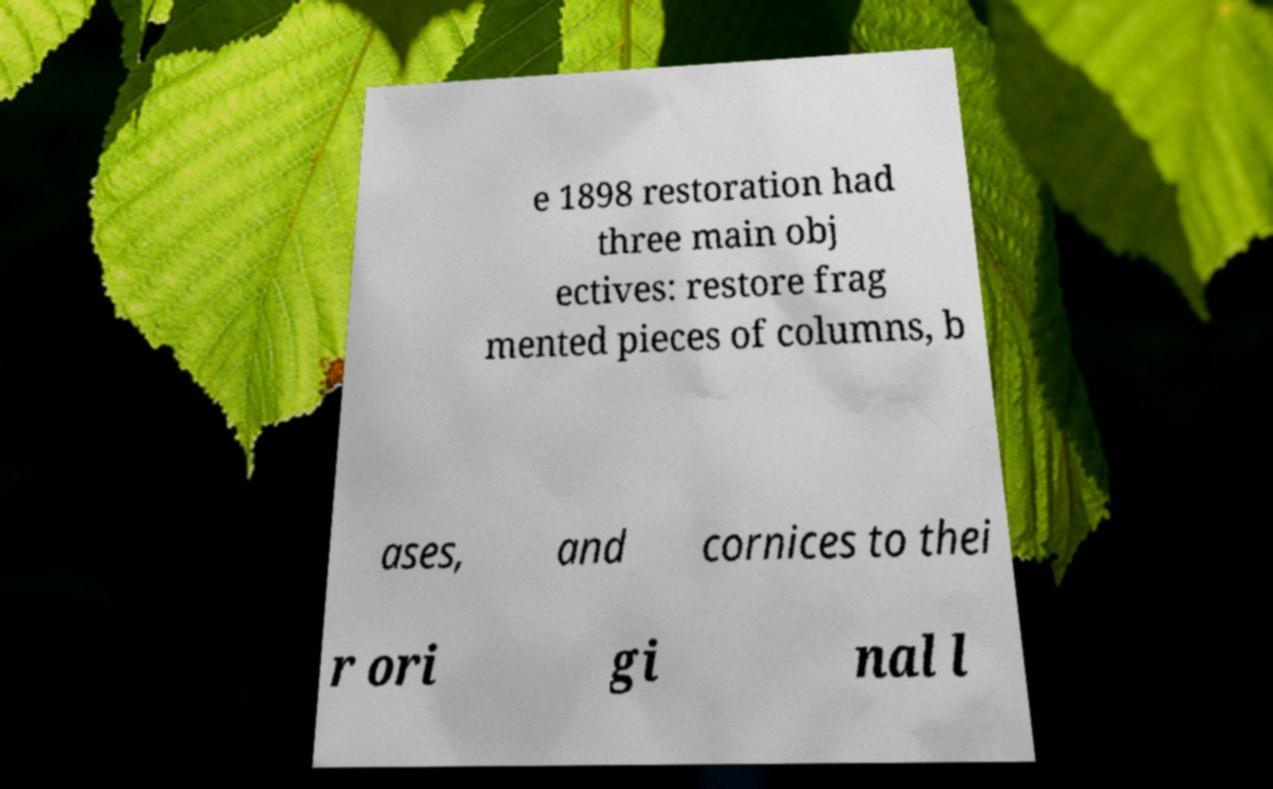Could you assist in decoding the text presented in this image and type it out clearly? e 1898 restoration had three main obj ectives: restore frag mented pieces of columns, b ases, and cornices to thei r ori gi nal l 